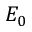<formula> <loc_0><loc_0><loc_500><loc_500>E _ { 0 }</formula> 